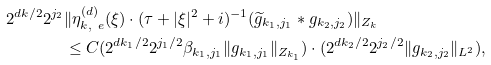<formula> <loc_0><loc_0><loc_500><loc_500>2 ^ { d k / 2 } 2 ^ { j _ { 2 } } & \| \eta _ { k , \ e } ^ { ( d ) } ( \xi ) \cdot ( \tau + | \xi | ^ { 2 } + i ) ^ { - 1 } ( \widetilde { g } _ { k _ { 1 } , j _ { 1 } } \ast g _ { k _ { 2 } , j _ { 2 } } ) \| _ { Z _ { k } } \\ & \leq C ( 2 ^ { d k _ { 1 } / 2 } 2 ^ { j _ { 1 } / 2 } \beta _ { k _ { 1 } , j _ { 1 } } \| g _ { k _ { 1 } , j _ { 1 } } \| _ { Z _ { k _ { 1 } } } ) \cdot ( 2 ^ { d k _ { 2 } / 2 } 2 ^ { j _ { 2 } / 2 } \| g _ { k _ { 2 } , j _ { 2 } } \| _ { L ^ { 2 } } ) ,</formula> 